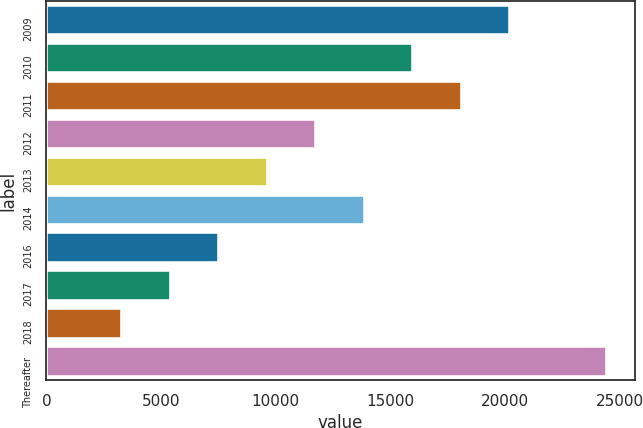Convert chart to OTSL. <chart><loc_0><loc_0><loc_500><loc_500><bar_chart><fcel>2009<fcel>2010<fcel>2011<fcel>2012<fcel>2013<fcel>2014<fcel>2016<fcel>2017<fcel>2018<fcel>Thereafter<nl><fcel>20212<fcel>15985<fcel>18098.5<fcel>11758<fcel>9644.5<fcel>13871.5<fcel>7531<fcel>5417.5<fcel>3304<fcel>24439<nl></chart> 